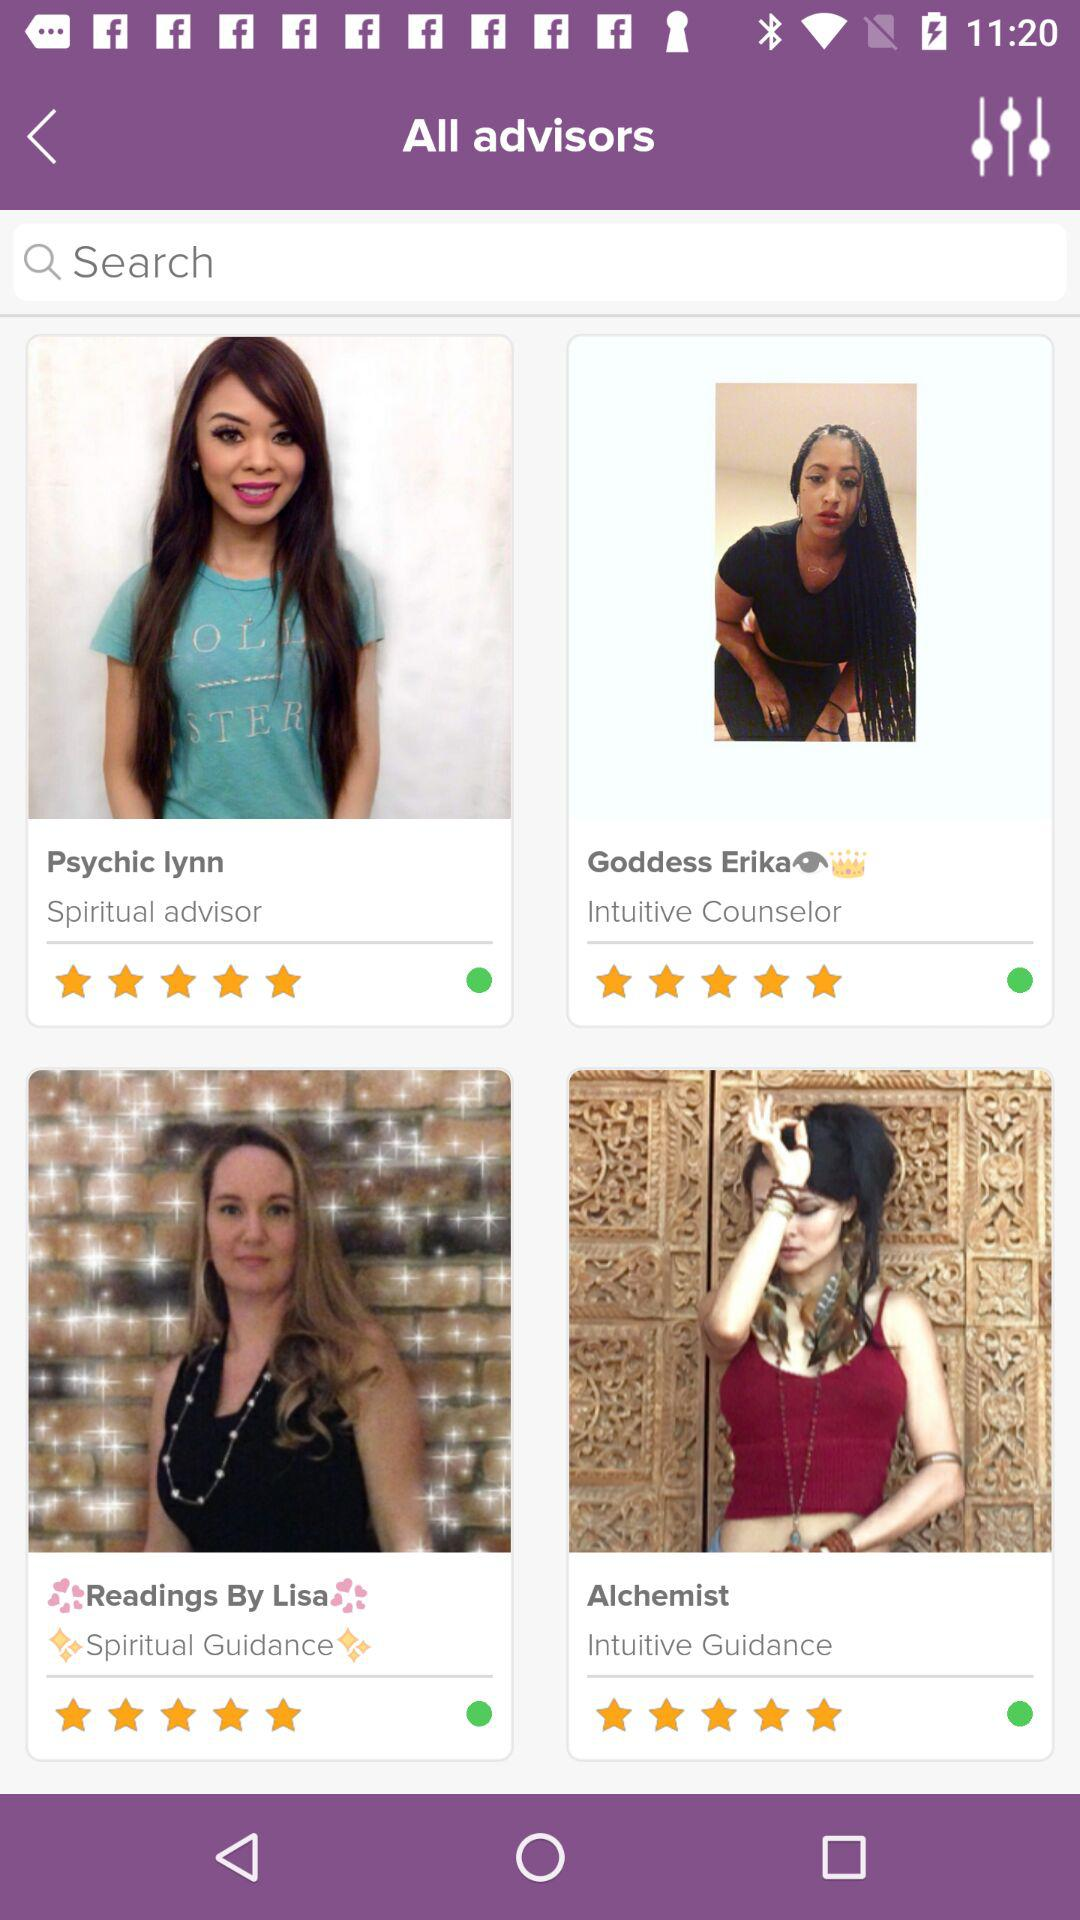What type of advisor is Psychic Lynn? Psychic Lynn is a "Spiritual" type of advisor. 